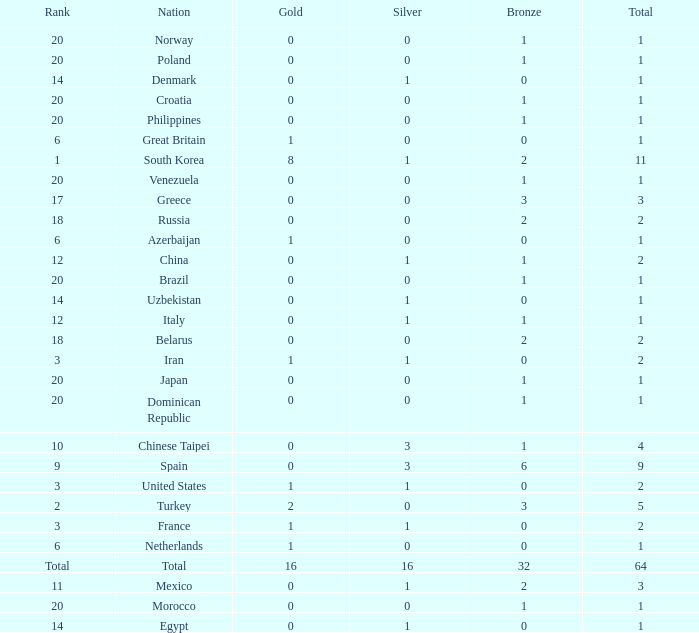What is the average number of bronze of the nation with more than 1 gold and 1 silver medal? 2.0. 